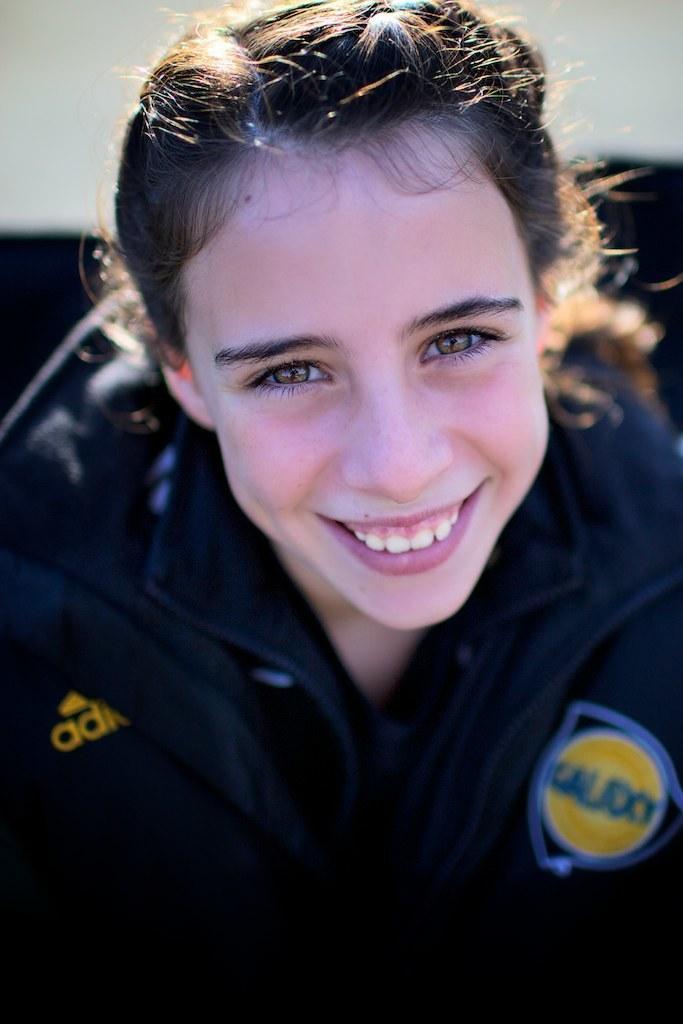In one or two sentences, can you explain what this image depicts? In this image, we can see a woman is watching and smiling. At the bottom of the image, we can see a blur view. 